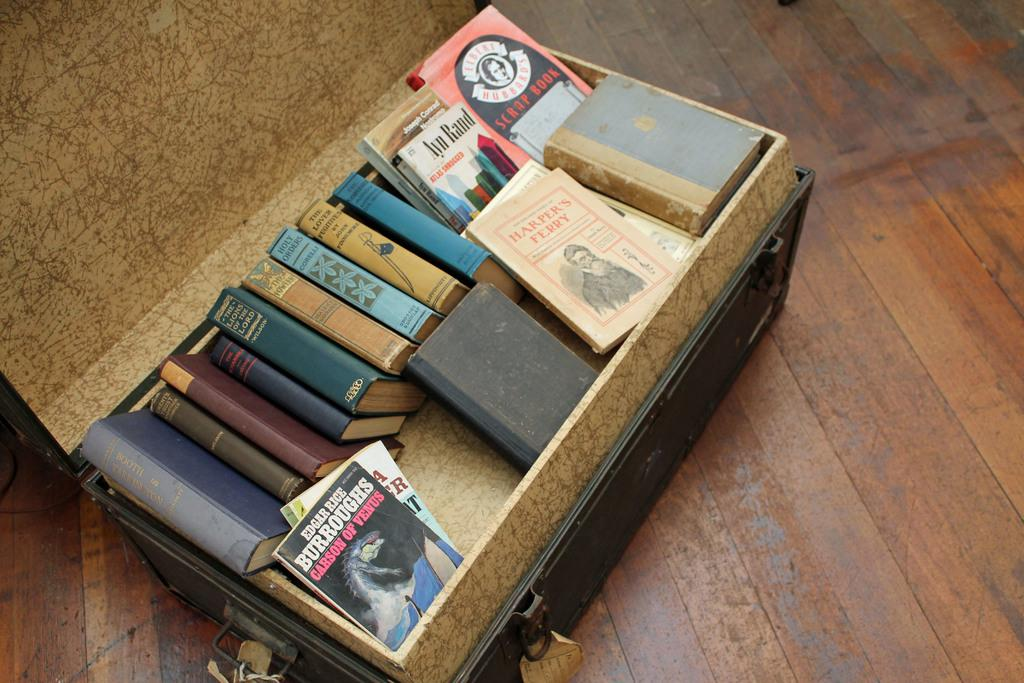<image>
Provide a brief description of the given image. A chest full of books is displayed, one of which from the author Edgar Rice 